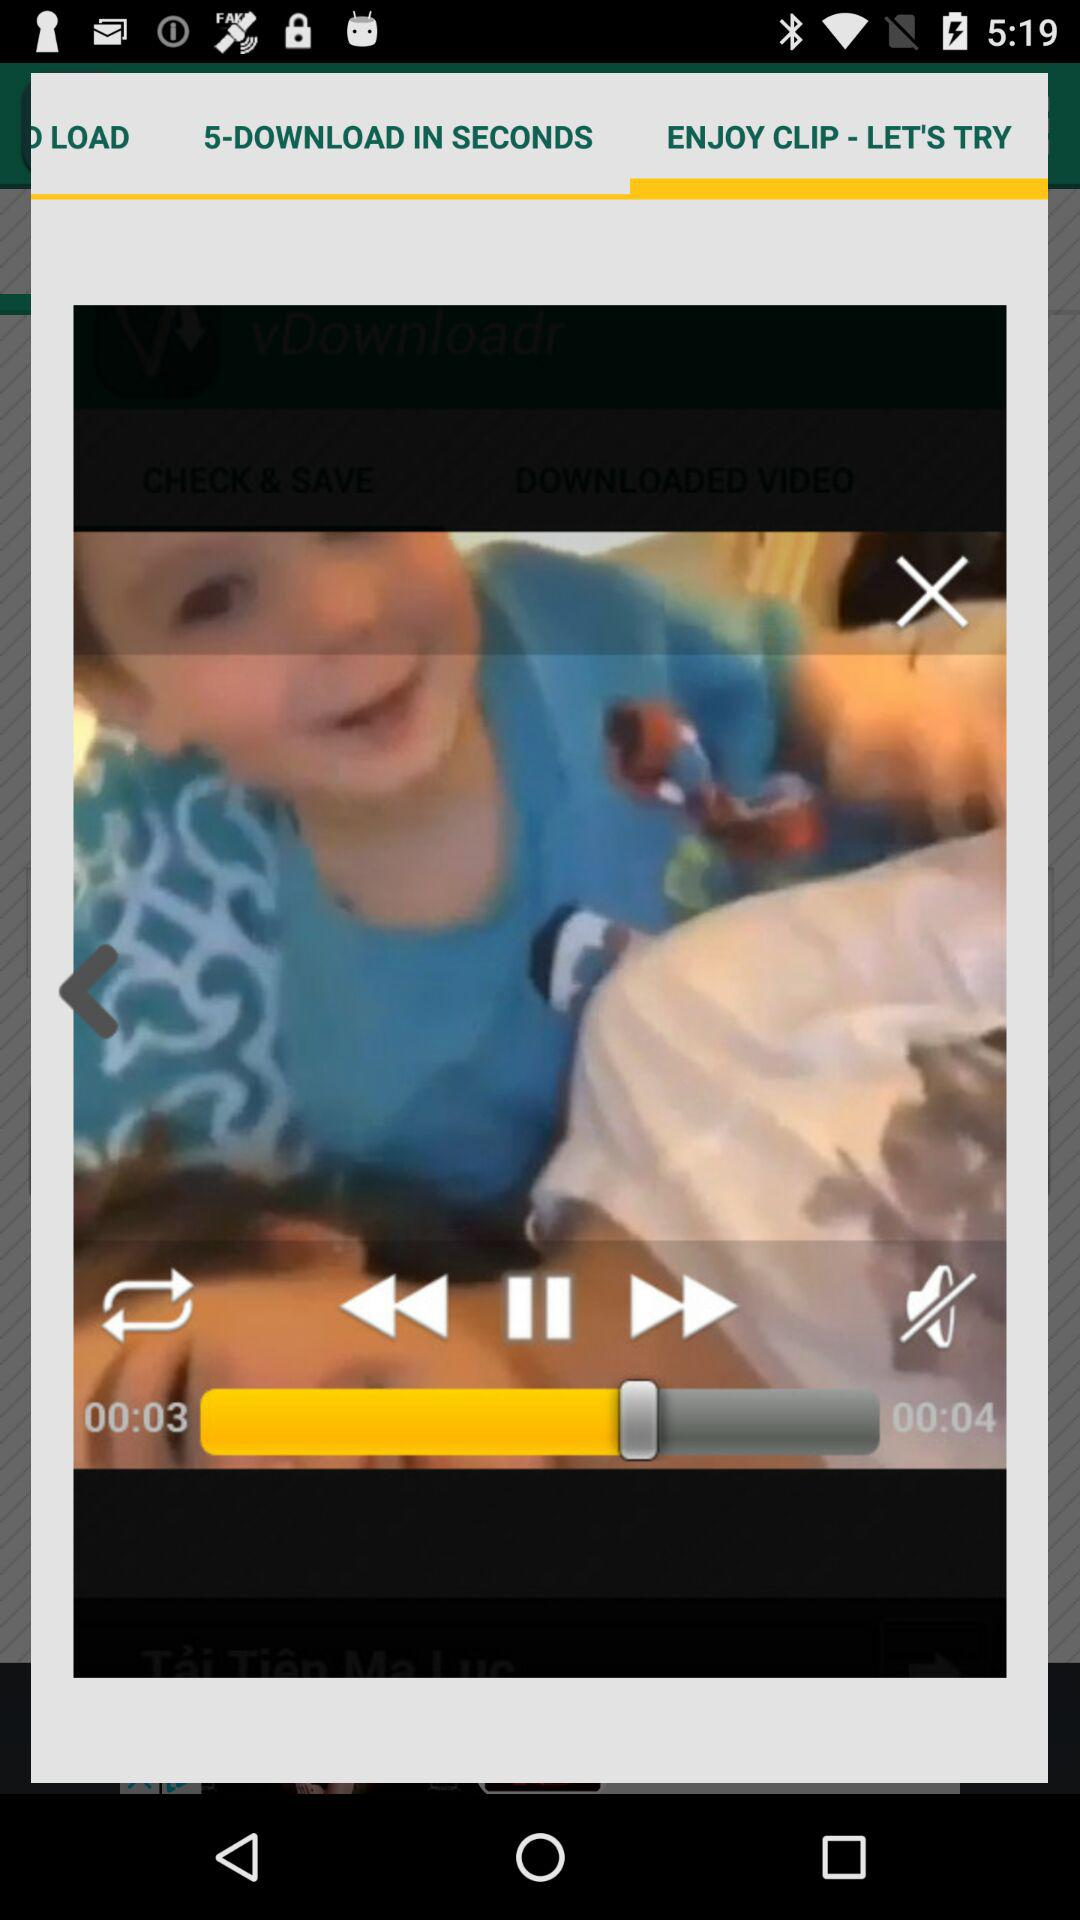What is the video's overall runtime? The video's overall runtime is 4 seconds. 